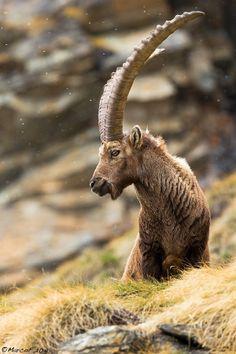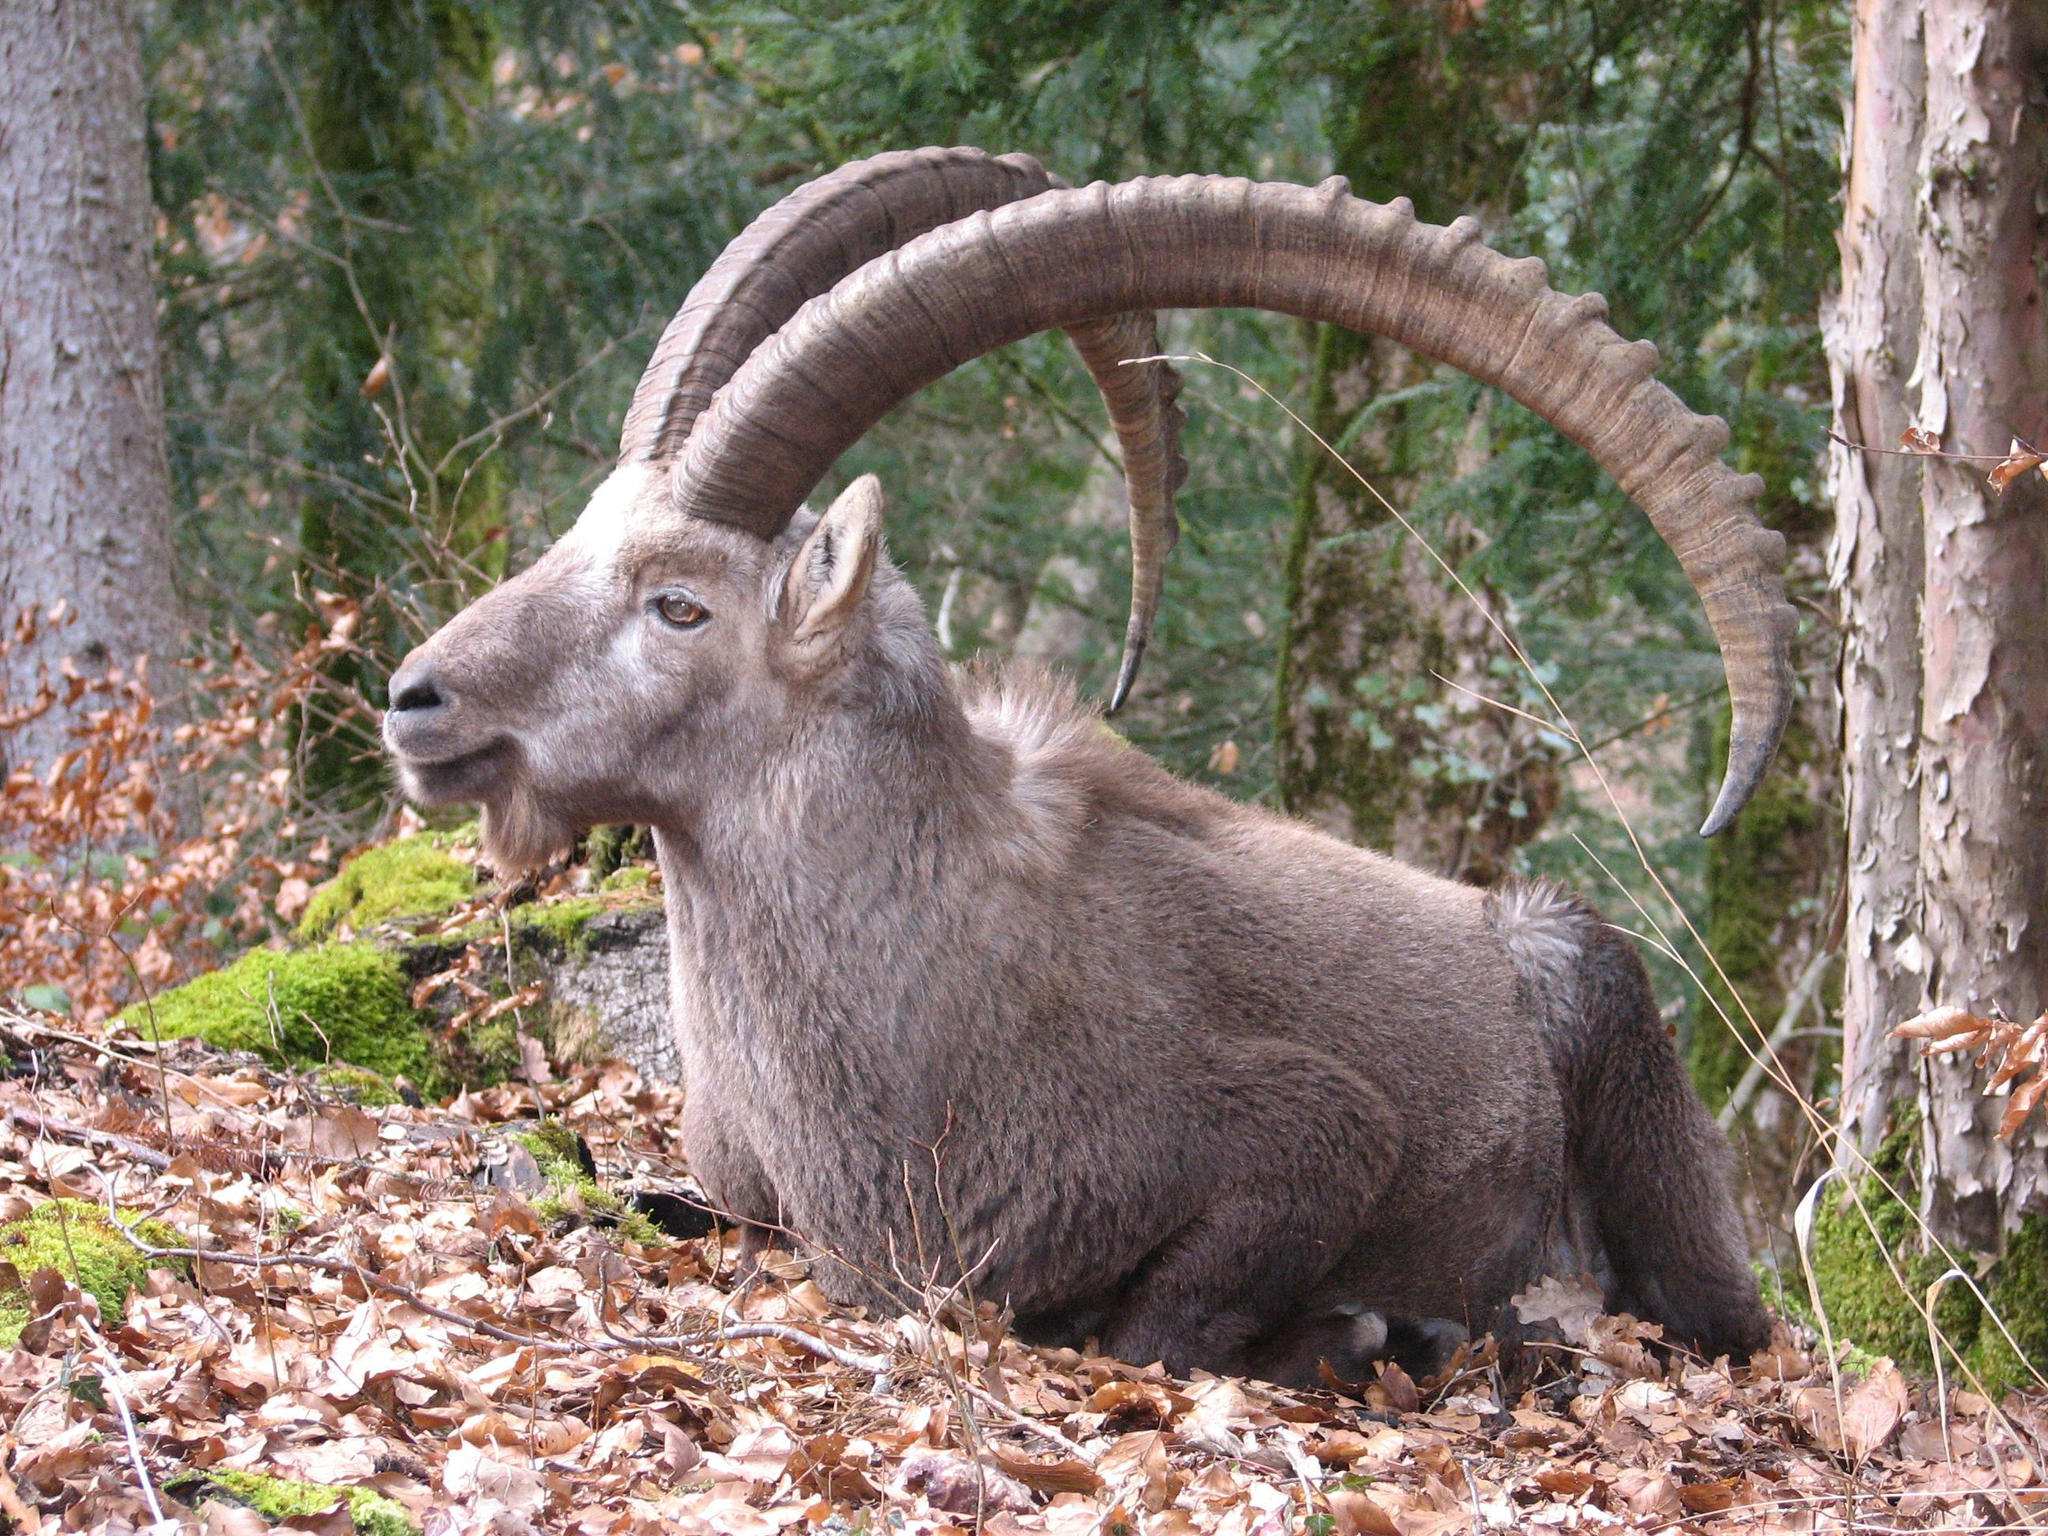The first image is the image on the left, the second image is the image on the right. Assess this claim about the two images: "In 1 of the images, 1 of the goats is seated.". Correct or not? Answer yes or no. Yes. The first image is the image on the left, the second image is the image on the right. Assess this claim about the two images: "Left image shows a horned animal standing on non-grassy surface with body and head in profile turned leftward.". Correct or not? Answer yes or no. No. 